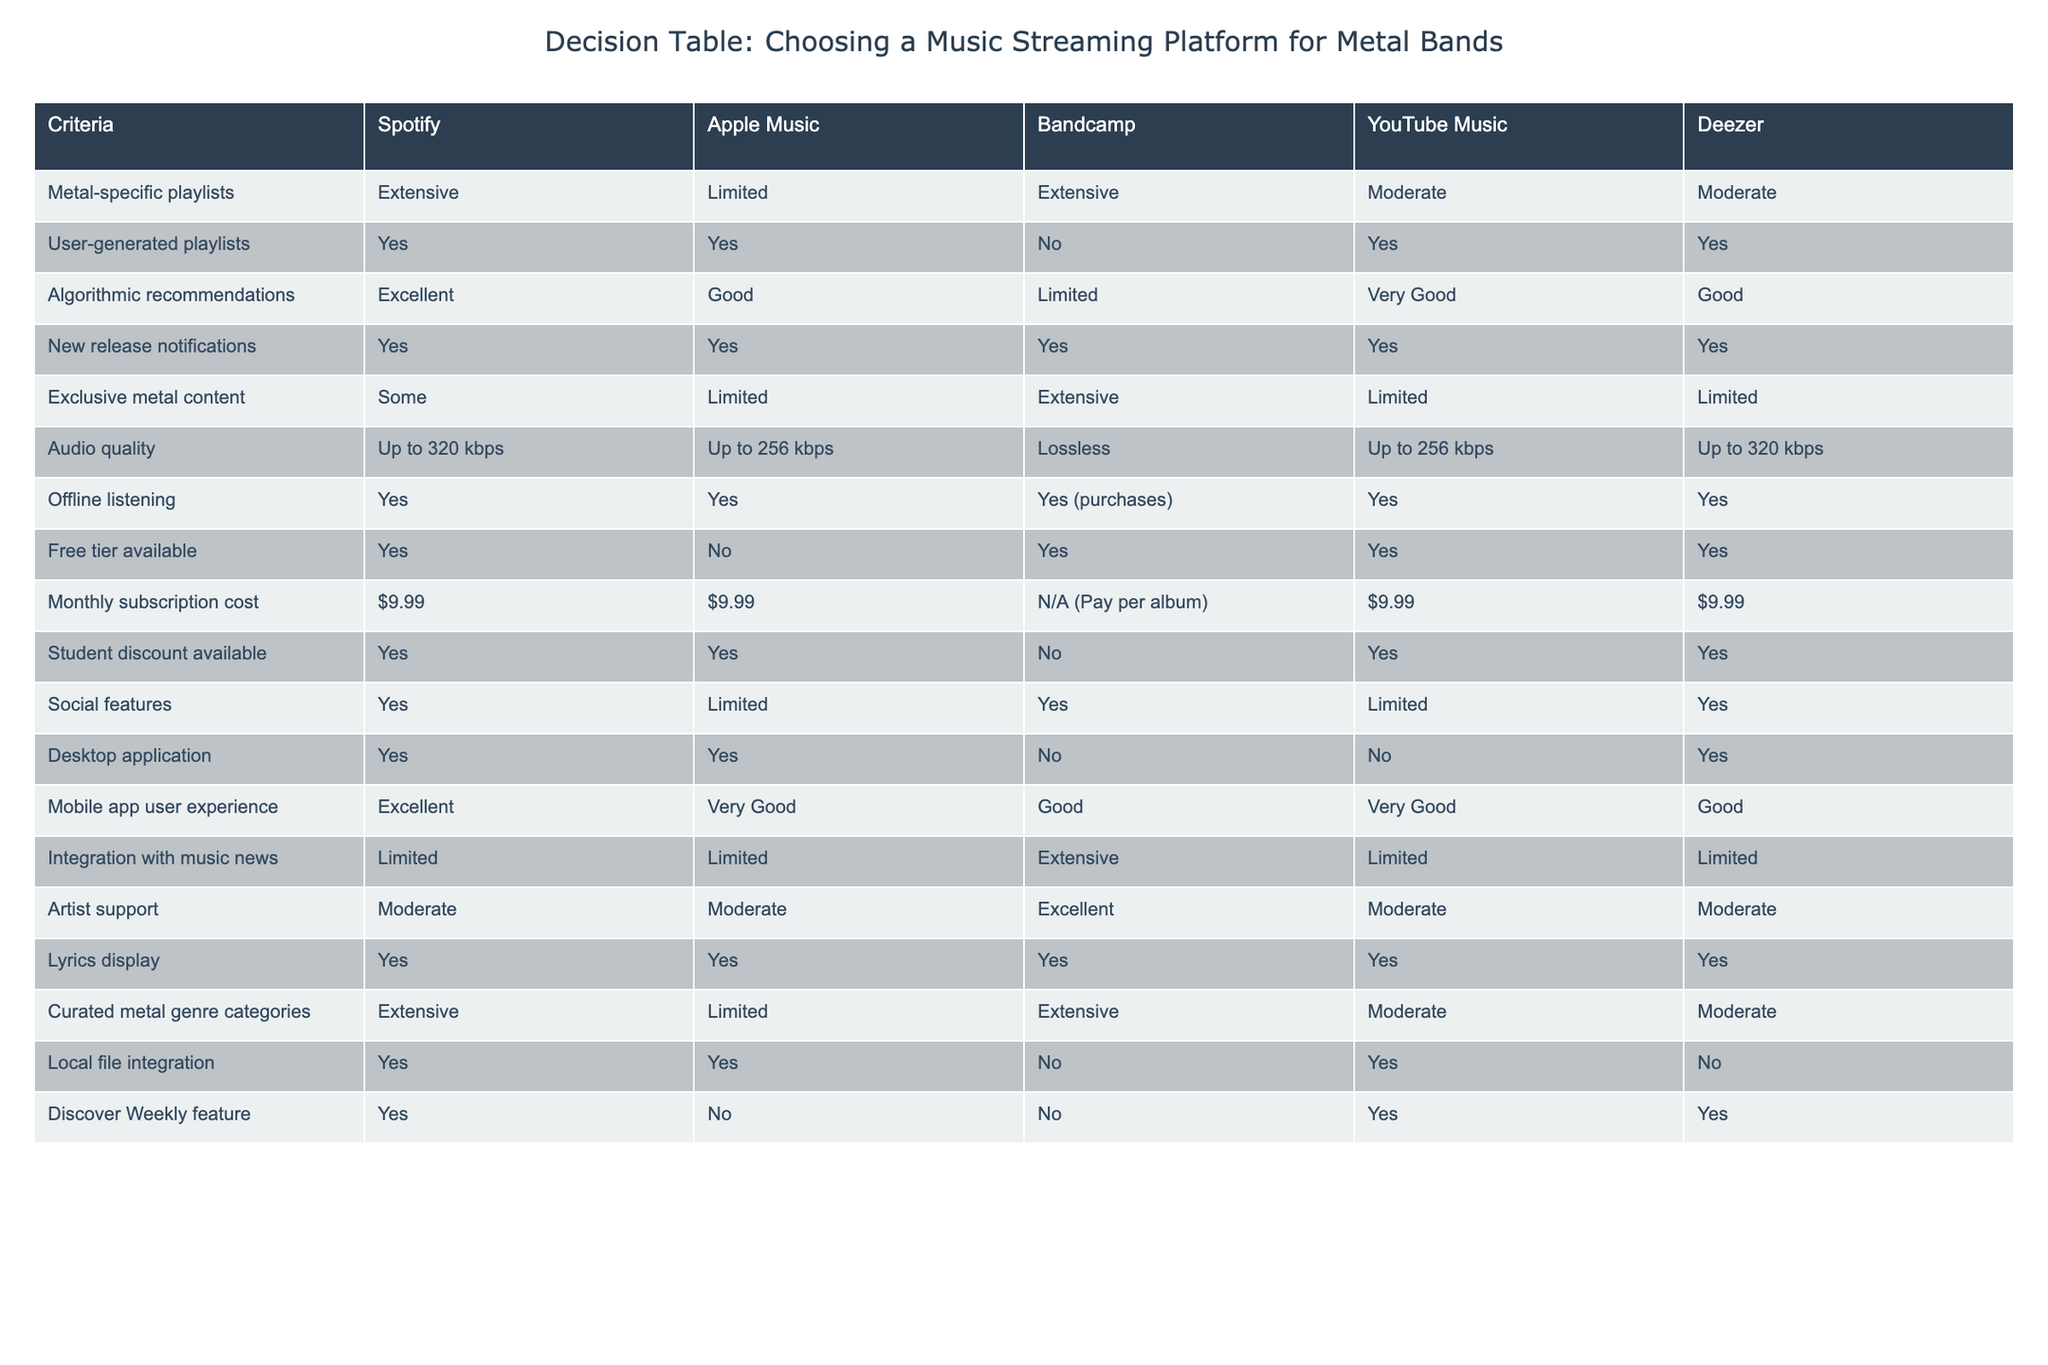What streaming platform offers extensive metal-specific playlists? If we look at the column for metal-specific playlists, both Spotify and Bandcamp are marked as "Extensive." So, these are the platforms that offer a significant number of curated metal playlists for discovery.
Answer: Spotify and Bandcamp Does Deezer provide a free tier for users? Checking the "Free tier available" row, Deezer has "Yes" indicated. This means that users can access Deezer without a subscription, making it easier for new listeners to explore.
Answer: Yes Which platform has the best audio quality? The "Audio quality" row shows that Bandcamp offers Lossless quality, meaning that it has the highest audio fidelity of the platforms listed. This can be especially important for audiophiles or serious music fans.
Answer: Bandcamp How many platforms offer exclusive metal content? By observing the "Exclusive metal content" row, we see that the platforms with "Extensive" inclusion are Bandcamp (1) and Spotify (some, not as extensive). Therefore, the total number of platforms offering exclusive metal content is two.
Answer: 2 Which platform has the most extensive curated metal genre categories? In the "Curated metal genre categories" row, we find that Spotify and Bandcamp both have "Extensive," while the others are either moderate or limited. This implies that Spotify and Bandcamp are the best choices for those who want categorically rich metal music.
Answer: Spotify and Bandcamp Is there a platform that allows for offline listening without a subscription? Examining the row for "Offline listening," only Bandcamp indicates "Yes (purchases)," but this means it requires buying the music rather than simply subscribing. The other platforms allow offline features as part of their subscription, thus no platform offers it without payment.
Answer: No On which platform is the user experience for the mobile app rated as excellent? The "Mobile app user experience" row shows that Spotify has been rated as "Excellent," indicating it provides a top-quality user experience for mobile users.
Answer: Spotify Which music streaming platform has a limited number of user-generated playlists? By checking the "User-generated playlists" row, we observe that Bandcamp shows "No," indicating it does not support user-generated playlists. This highlights a limitation for users who value community-driven discoveries.
Answer: Bandcamp How does the subscription cost compare between the platforms? When analyzing the "Monthly subscription cost" row, all platforms except Bandcamp (which uses a pay-per-album model) have a cost of $9.99. There is no variation in monthly subscription costs across most of the platforms. Hence, the user can choose based on preference rather than price.
Answer: $9.99 (except Bandcamp) 